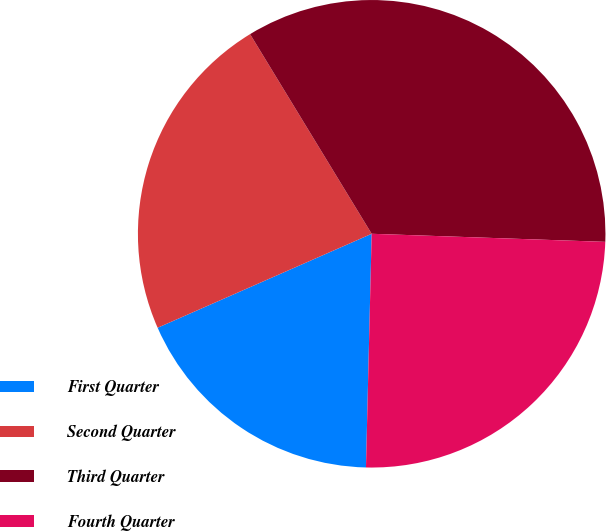Convert chart to OTSL. <chart><loc_0><loc_0><loc_500><loc_500><pie_chart><fcel>First Quarter<fcel>Second Quarter<fcel>Third Quarter<fcel>Fourth Quarter<nl><fcel>18.03%<fcel>22.88%<fcel>34.26%<fcel>24.84%<nl></chart> 